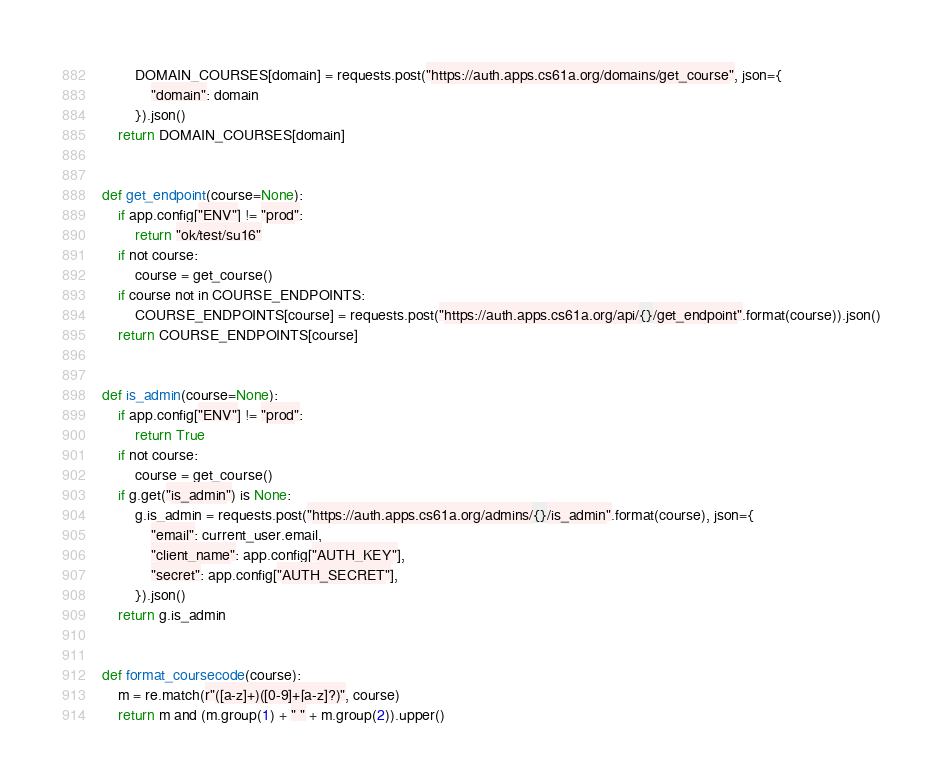Convert code to text. <code><loc_0><loc_0><loc_500><loc_500><_Python_>        DOMAIN_COURSES[domain] = requests.post("https://auth.apps.cs61a.org/domains/get_course", json={
            "domain": domain
        }).json()
    return DOMAIN_COURSES[domain]


def get_endpoint(course=None):
    if app.config["ENV"] != "prod":
        return "ok/test/su16"
    if not course:
        course = get_course()
    if course not in COURSE_ENDPOINTS:
        COURSE_ENDPOINTS[course] = requests.post("https://auth.apps.cs61a.org/api/{}/get_endpoint".format(course)).json()
    return COURSE_ENDPOINTS[course]


def is_admin(course=None):
    if app.config["ENV"] != "prod":
        return True
    if not course:
        course = get_course()
    if g.get("is_admin") is None:
        g.is_admin = requests.post("https://auth.apps.cs61a.org/admins/{}/is_admin".format(course), json={
            "email": current_user.email,
            "client_name": app.config["AUTH_KEY"],
            "secret": app.config["AUTH_SECRET"],
        }).json()
    return g.is_admin


def format_coursecode(course):
    m = re.match(r"([a-z]+)([0-9]+[a-z]?)", course)
    return m and (m.group(1) + " " + m.group(2)).upper()
</code> 